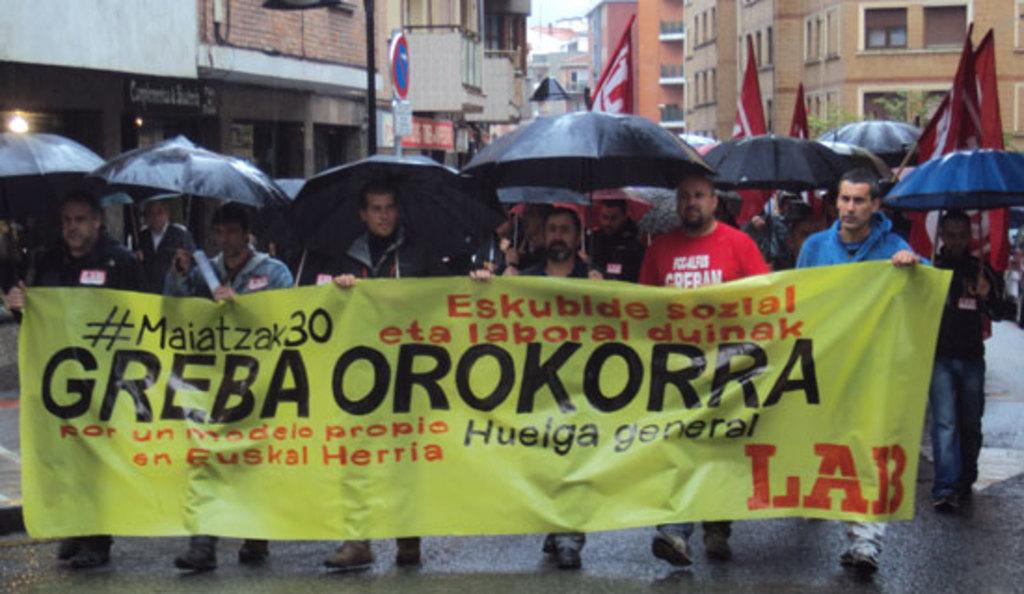How many people are in the image? There are people in the image, but the exact number is not specified. What are some people holding in the image? Some people are holding banners in the image. What can be used for protection from rain or sun in the image? Umbrellas are visible in the image. What type of signage is present in the image? Banners are present in the image. What can be seen in the background of the image? In the background of the image, there are boards on poles, buildings, a tree, light, and the sky. What type of cake is being cut by the person holding a pen in the image? There is no person holding a pen or any cake present in the image. 